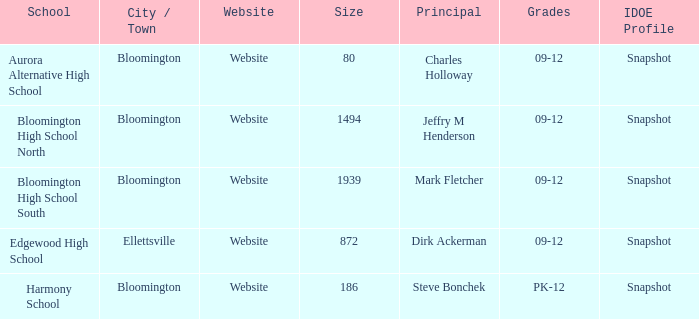Where is Bloomington High School North? Bloomington. 